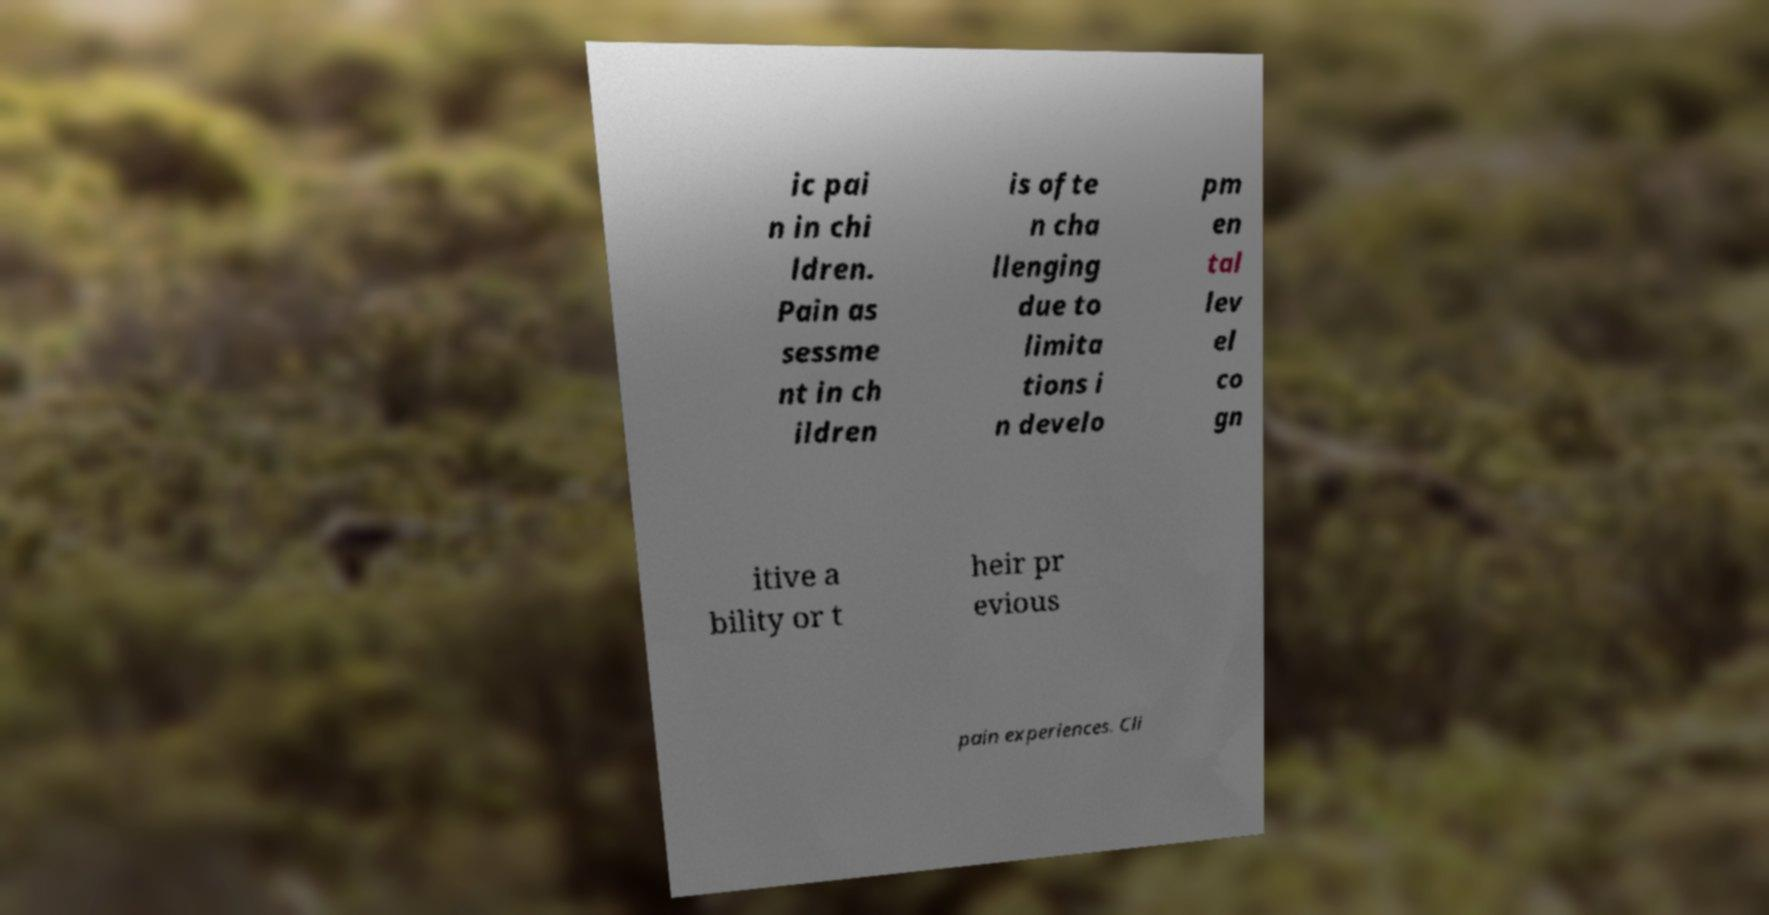For documentation purposes, I need the text within this image transcribed. Could you provide that? ic pai n in chi ldren. Pain as sessme nt in ch ildren is ofte n cha llenging due to limita tions i n develo pm en tal lev el co gn itive a bility or t heir pr evious pain experiences. Cli 